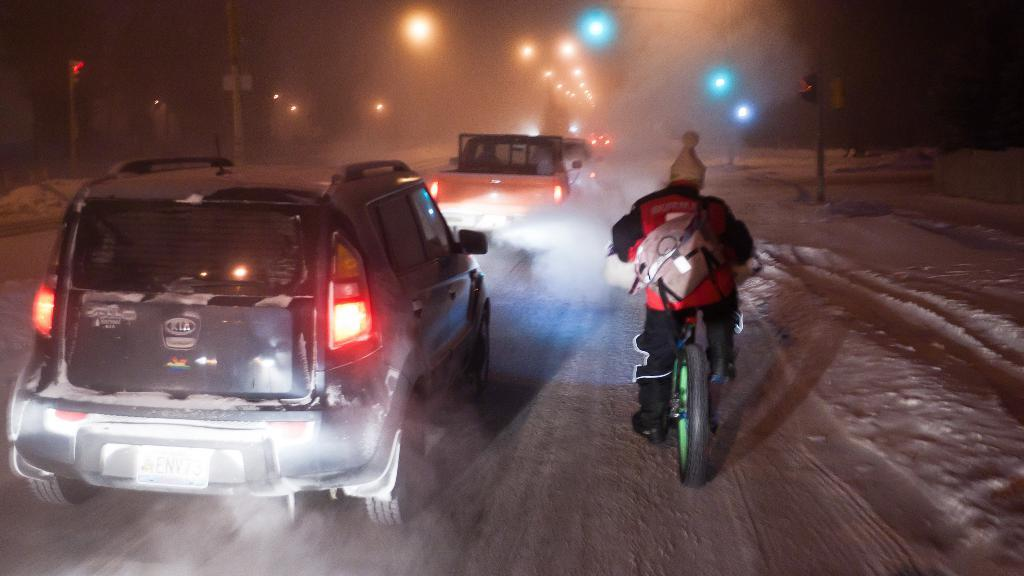What type of vehicle is located on the left side of the image? There is a car in the foreground on the left side of the image. What type of transportation is on the right side of the image? There is a bicycle in the foreground on the right side of the image. What type of adjustment can be seen on the car's windshield in the image? There is no adjustment visible on the car's windshield in the image. What type of plate is present on the bicycle in the image? There is no plate visible on the bicycle in the image. 